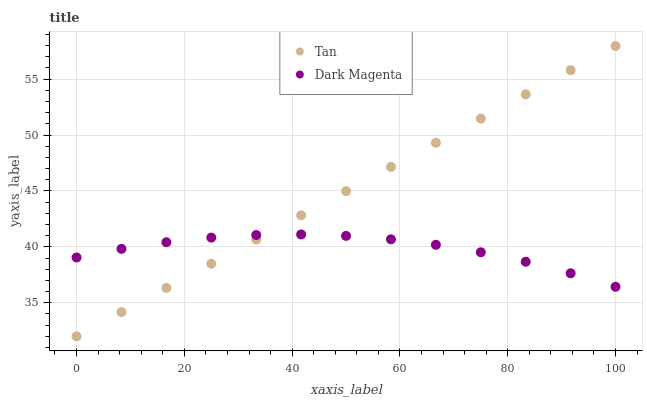Does Dark Magenta have the minimum area under the curve?
Answer yes or no. Yes. Does Tan have the maximum area under the curve?
Answer yes or no. Yes. Does Dark Magenta have the maximum area under the curve?
Answer yes or no. No. Is Tan the smoothest?
Answer yes or no. Yes. Is Dark Magenta the roughest?
Answer yes or no. Yes. Is Dark Magenta the smoothest?
Answer yes or no. No. Does Tan have the lowest value?
Answer yes or no. Yes. Does Dark Magenta have the lowest value?
Answer yes or no. No. Does Tan have the highest value?
Answer yes or no. Yes. Does Dark Magenta have the highest value?
Answer yes or no. No. Does Tan intersect Dark Magenta?
Answer yes or no. Yes. Is Tan less than Dark Magenta?
Answer yes or no. No. Is Tan greater than Dark Magenta?
Answer yes or no. No. 